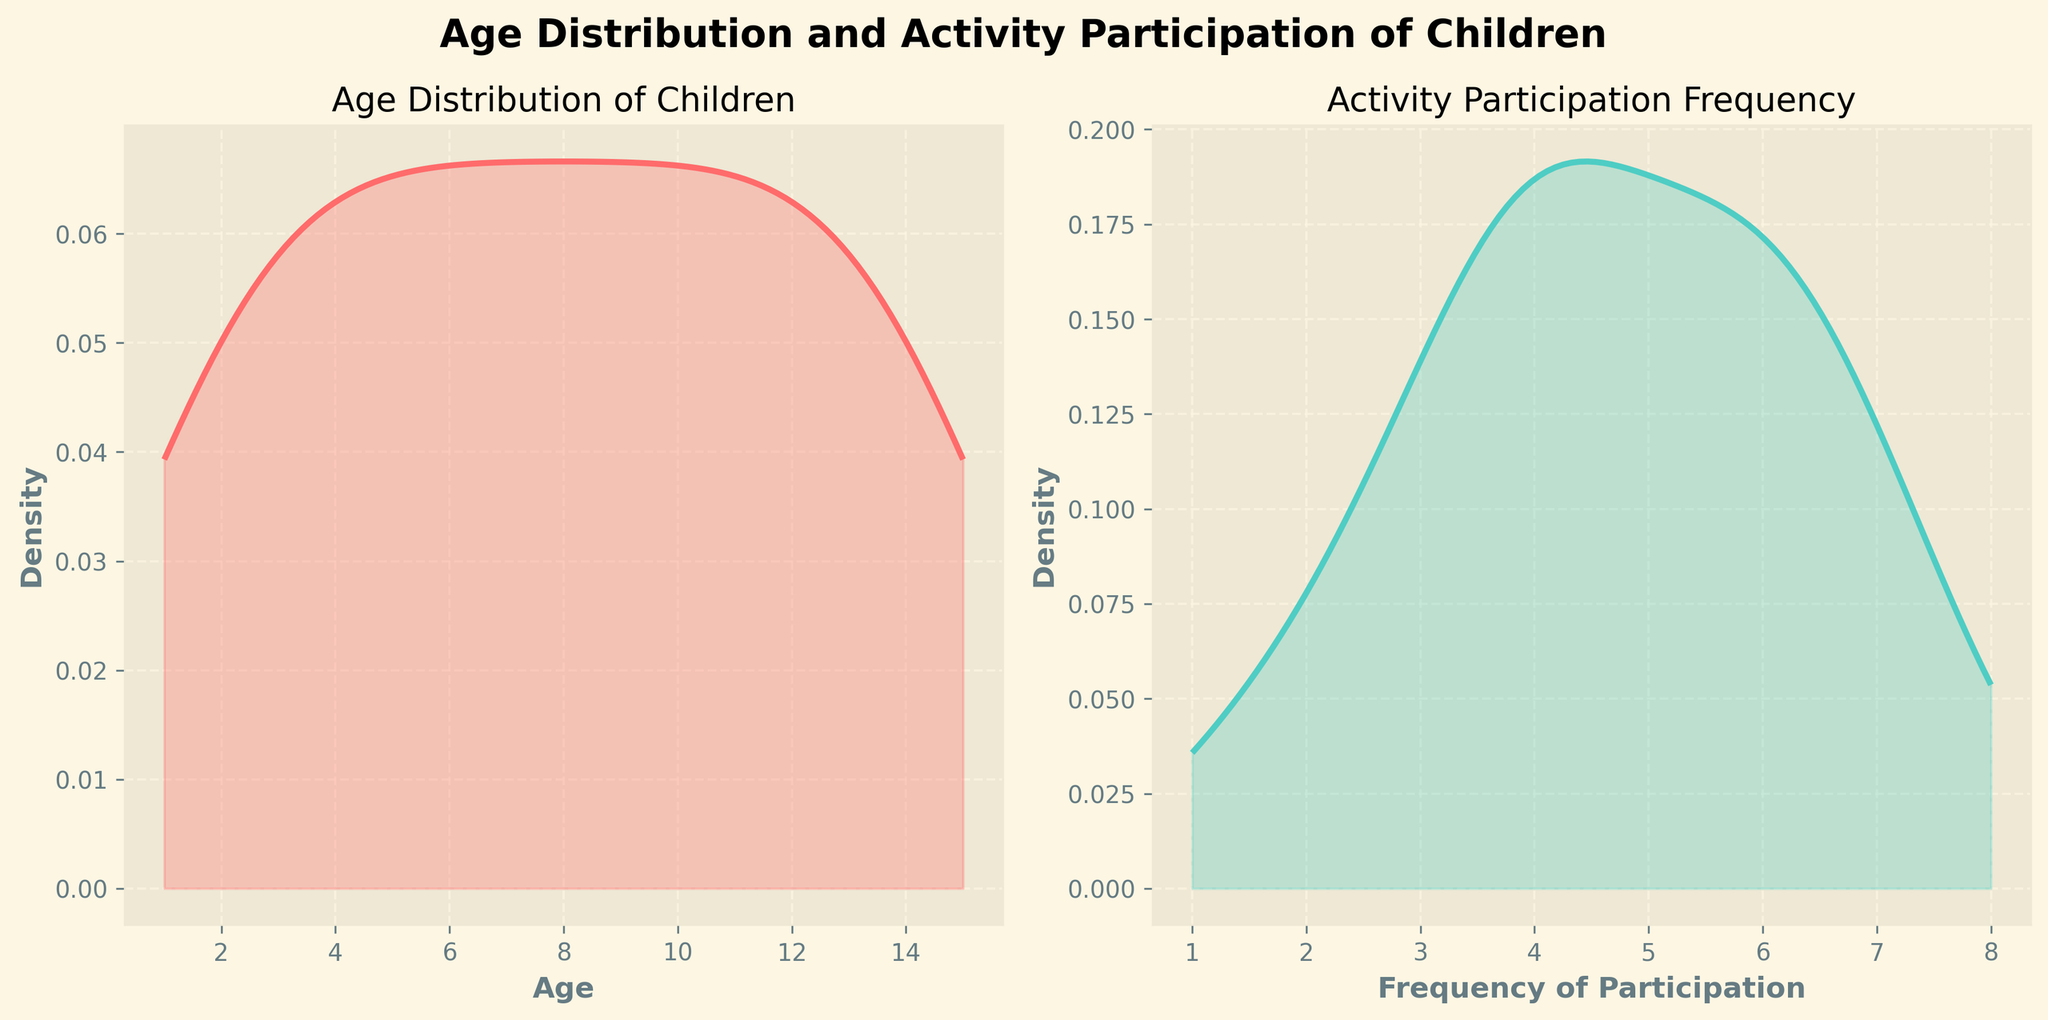What is the title of the subplot on the left side of the figure? The title of the subplot on the left side is typically placed above the plot. From the description, we know it is 'Age Distribution of Children'.
Answer: Age Distribution of Children What age range has the highest density in the Age Distribution subplot? By observing the density plot on the left side, the peak of the density curve represents the age range with the highest density.
Answer: Around 11-12 years old What is the title of the subplot on the right side of the figure? The title of the subplot on the right side is typically placed above the plot. From the description, we know it is 'Activity Participation Frequency'.
Answer: Activity Participation Frequency Which frequency of activity participation has the highest density? We refer to the peak of the density curve in the right plot of the Activity Participation Frequency. According to the provided data and KDE estimation, the highest density is around 7-8 times participation.
Answer: Around 7-8 times How does the density of 5-year-olds compare to 5 instances of activity participation? Comparing the density plots, we check the height of the density curves at age 5 and frequency 5. In both cases, the peaks are fairly prominent, so they seem comparable.
Answer: Similar How does the participation frequency distribution between 3 and 4 compare to the participation frequency between 8 and 9? We look at the density plot on the right from the KDE curves for frequencies between 3 to 4 and 8 to 9. The density of 3 to 4 participation frequencies is notably lower compared to 8 to 9 frequencies, where the density appears nearly at the highest point.
Answer: Higher between 8 and 9 In which density plot is the spread of data wider, the Age Distribution or the Activity Participation Frequency? To determine the spread of data in each density plot, compare the range in x-axis covered by the density curves. The Age Distribution plot spans from 1 to 15, while the Activity Participation spans from 2 to 8. Therefore, the wider spread appears in the Age Distribution plot.
Answer: Age Distribution What is the approximate density value for age 10? Referring to the density curve in the Age Distribution subplot, the density at age 10 can be observed just below its peak, near 0.09.
Answer: Around 0.09 Is the distribution of activity participation frequency unimodal or multimodal? Unimodal distribution means one clear peak, while multimodal has multiple peaks. Observing the density plot of the Activity Participation Frequency, we see it has one prominent peak, thus it is unimodal.
Answer: Unimodal What can be inferred about the overall number of children compared to their activity participation frequencies? By comparing both density plots, one can infer that children aged about 11-12 years show a significant density resembling high instances of activity frequency around 7-8 times, implying high overlaps between age and activity participation.
Answer: Higher activity frequencies for around 11-12 years of age 